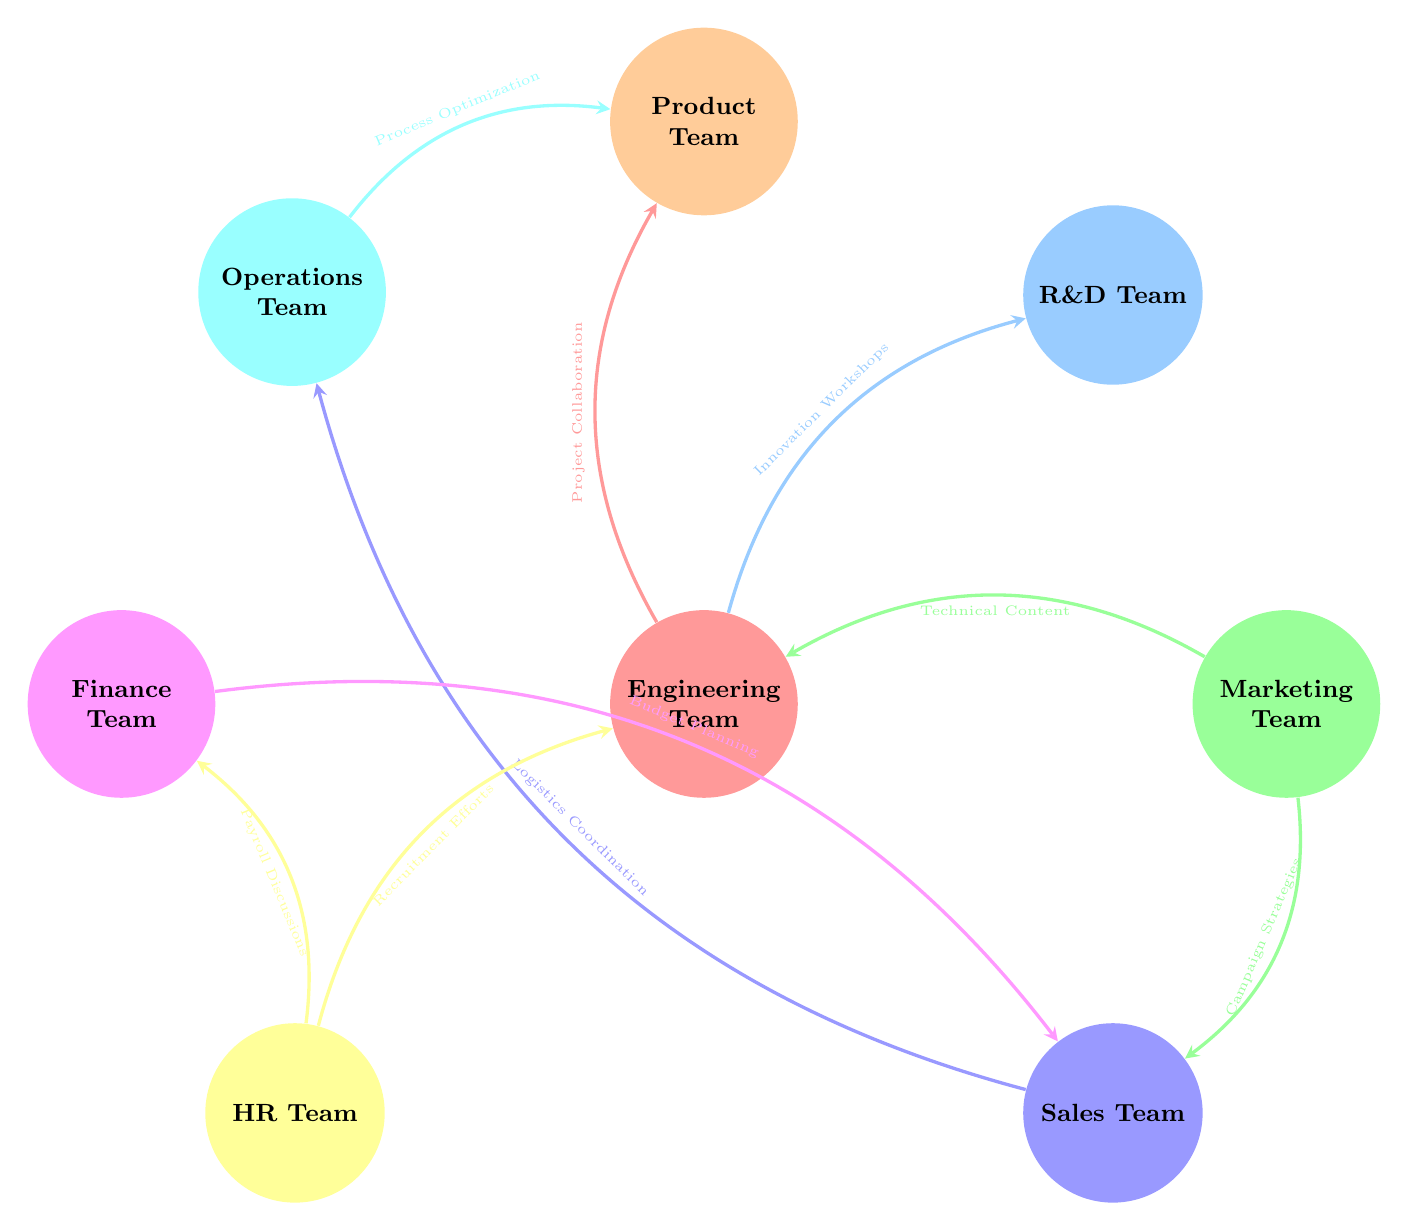What is the interaction between the Engineering Team and the Product Team? The link connecting the Engineering Team and the Product Team is labeled "Project Collaboration," which describes the type of interaction they have.
Answer: Project Collaboration How many teams are connected to the Sales Team? By examining the diagram, we can see that the Sales Team is directly linked to three other teams: Marketing Team, Operations Team, and Finance Team. Hence, counting these connections gives a total of three teams.
Answer: 3 What is the value of the link between Marketing Team and Sales Team? The link between Marketing Team and Sales Team has a value of 15 as indicated by the thickness of that line in the diagram.
Answer: 15 Which department has the least number of interactions shown in the diagram? By looking at the connections, HR Team interacts with the Finance Team, Engineering Team, and has the lowest total interaction value of 9 (5 for Payroll Discussions and 4 for Recruitment Efforts), which is the least among all departments with more than one connection.
Answer: HR Team Which two teams have the highest interaction value? In the diagram, the connection between the Marketing Team and Sales Team with a value of 15 is the highest among all the interactions indicated.
Answer: Marketing Team and Sales Team What is the total number of links represented in the diagram? Counting all the connections depicted in the diagram yields a total of 8 links, as each connection between departments is represented as a distinct edge.
Answer: 8 What is the interaction type between the Operations Team and the Product Team? The link connecting the Operations Team to the Product Team indicates the interaction type as "Process Optimization," which specifies the nature of their collaboration.
Answer: Process Optimization How does the Engineering Team interact with the HR Team? The Engineering Team interacts with the HR Team through an interaction labeled "Recruitment Efforts," and this describes the nature of their collaboration pertaining to hiring opportunities.
Answer: Recruitment Efforts 